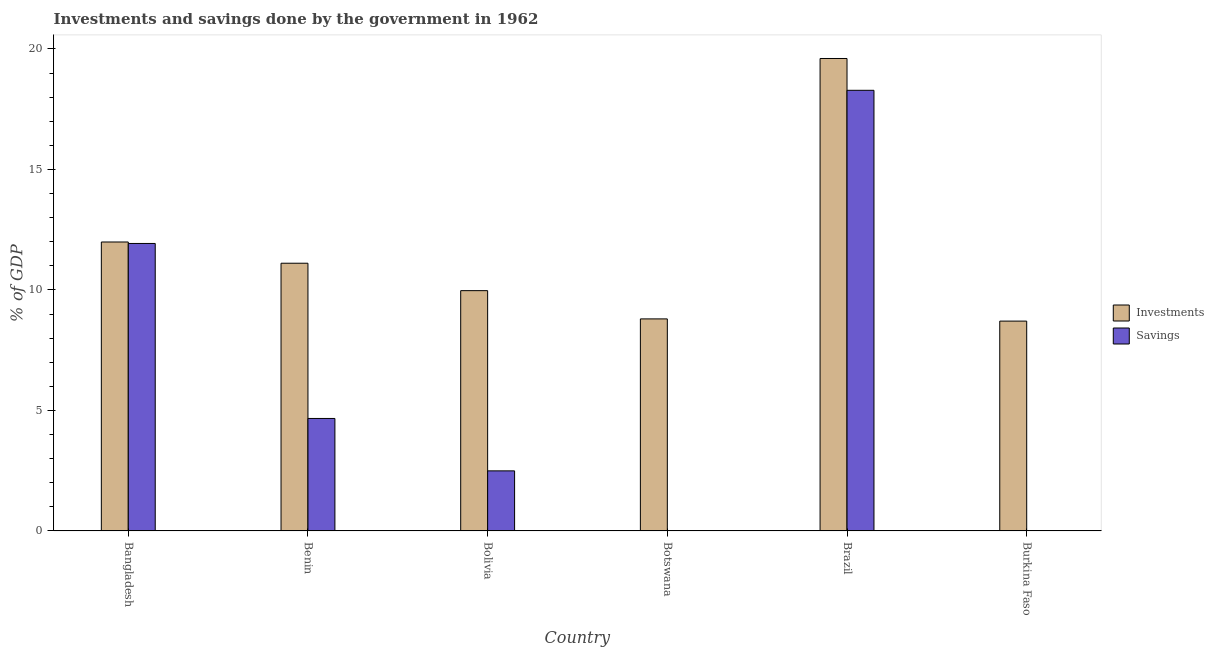How many different coloured bars are there?
Your response must be concise. 2. Are the number of bars per tick equal to the number of legend labels?
Provide a succinct answer. No. How many bars are there on the 3rd tick from the left?
Give a very brief answer. 2. How many bars are there on the 5th tick from the right?
Give a very brief answer. 2. What is the investments of government in Bangladesh?
Provide a short and direct response. 11.99. Across all countries, what is the maximum savings of government?
Your answer should be compact. 18.28. Across all countries, what is the minimum savings of government?
Provide a succinct answer. 0. In which country was the investments of government maximum?
Give a very brief answer. Brazil. What is the total savings of government in the graph?
Ensure brevity in your answer.  37.37. What is the difference between the investments of government in Benin and that in Brazil?
Offer a terse response. -8.5. What is the difference between the investments of government in Burkina Faso and the savings of government in Botswana?
Keep it short and to the point. 8.71. What is the average savings of government per country?
Ensure brevity in your answer.  6.23. What is the difference between the investments of government and savings of government in Bangladesh?
Offer a terse response. 0.06. What is the ratio of the investments of government in Bangladesh to that in Brazil?
Your answer should be very brief. 0.61. Is the investments of government in Botswana less than that in Brazil?
Ensure brevity in your answer.  Yes. Is the difference between the savings of government in Bangladesh and Brazil greater than the difference between the investments of government in Bangladesh and Brazil?
Provide a short and direct response. Yes. What is the difference between the highest and the second highest savings of government?
Offer a very short reply. 6.36. What is the difference between the highest and the lowest savings of government?
Your response must be concise. 18.28. Is the sum of the investments of government in Bangladesh and Brazil greater than the maximum savings of government across all countries?
Keep it short and to the point. Yes. How many bars are there?
Provide a succinct answer. 10. What is the difference between two consecutive major ticks on the Y-axis?
Provide a succinct answer. 5. Does the graph contain grids?
Your answer should be very brief. No. Where does the legend appear in the graph?
Provide a succinct answer. Center right. How are the legend labels stacked?
Provide a short and direct response. Vertical. What is the title of the graph?
Offer a terse response. Investments and savings done by the government in 1962. Does "Investment in Telecom" appear as one of the legend labels in the graph?
Provide a succinct answer. No. What is the label or title of the Y-axis?
Your answer should be compact. % of GDP. What is the % of GDP of Investments in Bangladesh?
Ensure brevity in your answer.  11.99. What is the % of GDP in Savings in Bangladesh?
Make the answer very short. 11.93. What is the % of GDP of Investments in Benin?
Make the answer very short. 11.11. What is the % of GDP in Savings in Benin?
Provide a succinct answer. 4.67. What is the % of GDP of Investments in Bolivia?
Give a very brief answer. 9.97. What is the % of GDP of Savings in Bolivia?
Offer a very short reply. 2.49. What is the % of GDP in Investments in Botswana?
Give a very brief answer. 8.8. What is the % of GDP of Investments in Brazil?
Make the answer very short. 19.6. What is the % of GDP of Savings in Brazil?
Offer a very short reply. 18.28. What is the % of GDP in Investments in Burkina Faso?
Provide a succinct answer. 8.71. Across all countries, what is the maximum % of GDP of Investments?
Keep it short and to the point. 19.6. Across all countries, what is the maximum % of GDP of Savings?
Provide a succinct answer. 18.28. Across all countries, what is the minimum % of GDP of Investments?
Offer a terse response. 8.71. Across all countries, what is the minimum % of GDP in Savings?
Give a very brief answer. 0. What is the total % of GDP in Investments in the graph?
Offer a terse response. 70.18. What is the total % of GDP of Savings in the graph?
Your answer should be compact. 37.37. What is the difference between the % of GDP in Investments in Bangladesh and that in Benin?
Give a very brief answer. 0.88. What is the difference between the % of GDP of Savings in Bangladesh and that in Benin?
Provide a short and direct response. 7.26. What is the difference between the % of GDP of Investments in Bangladesh and that in Bolivia?
Your answer should be very brief. 2.02. What is the difference between the % of GDP in Savings in Bangladesh and that in Bolivia?
Your answer should be compact. 9.44. What is the difference between the % of GDP in Investments in Bangladesh and that in Botswana?
Your answer should be very brief. 3.19. What is the difference between the % of GDP in Investments in Bangladesh and that in Brazil?
Your answer should be very brief. -7.61. What is the difference between the % of GDP in Savings in Bangladesh and that in Brazil?
Provide a short and direct response. -6.36. What is the difference between the % of GDP of Investments in Bangladesh and that in Burkina Faso?
Your response must be concise. 3.28. What is the difference between the % of GDP of Investments in Benin and that in Bolivia?
Provide a succinct answer. 1.14. What is the difference between the % of GDP in Savings in Benin and that in Bolivia?
Give a very brief answer. 2.17. What is the difference between the % of GDP in Investments in Benin and that in Botswana?
Provide a short and direct response. 2.31. What is the difference between the % of GDP in Investments in Benin and that in Brazil?
Provide a succinct answer. -8.5. What is the difference between the % of GDP in Savings in Benin and that in Brazil?
Offer a terse response. -13.62. What is the difference between the % of GDP of Investments in Benin and that in Burkina Faso?
Your answer should be compact. 2.4. What is the difference between the % of GDP in Investments in Bolivia and that in Botswana?
Your answer should be compact. 1.17. What is the difference between the % of GDP of Investments in Bolivia and that in Brazil?
Your answer should be compact. -9.63. What is the difference between the % of GDP in Savings in Bolivia and that in Brazil?
Your answer should be very brief. -15.79. What is the difference between the % of GDP of Investments in Bolivia and that in Burkina Faso?
Offer a terse response. 1.26. What is the difference between the % of GDP in Investments in Botswana and that in Brazil?
Make the answer very short. -10.81. What is the difference between the % of GDP of Investments in Botswana and that in Burkina Faso?
Ensure brevity in your answer.  0.09. What is the difference between the % of GDP in Investments in Brazil and that in Burkina Faso?
Offer a terse response. 10.9. What is the difference between the % of GDP of Investments in Bangladesh and the % of GDP of Savings in Benin?
Provide a short and direct response. 7.32. What is the difference between the % of GDP in Investments in Bangladesh and the % of GDP in Savings in Bolivia?
Provide a succinct answer. 9.5. What is the difference between the % of GDP of Investments in Bangladesh and the % of GDP of Savings in Brazil?
Ensure brevity in your answer.  -6.29. What is the difference between the % of GDP in Investments in Benin and the % of GDP in Savings in Bolivia?
Keep it short and to the point. 8.62. What is the difference between the % of GDP in Investments in Benin and the % of GDP in Savings in Brazil?
Ensure brevity in your answer.  -7.18. What is the difference between the % of GDP of Investments in Bolivia and the % of GDP of Savings in Brazil?
Provide a short and direct response. -8.31. What is the difference between the % of GDP in Investments in Botswana and the % of GDP in Savings in Brazil?
Provide a short and direct response. -9.49. What is the average % of GDP of Investments per country?
Provide a succinct answer. 11.7. What is the average % of GDP of Savings per country?
Provide a succinct answer. 6.23. What is the difference between the % of GDP of Investments and % of GDP of Savings in Bangladesh?
Your answer should be very brief. 0.06. What is the difference between the % of GDP of Investments and % of GDP of Savings in Benin?
Provide a short and direct response. 6.44. What is the difference between the % of GDP of Investments and % of GDP of Savings in Bolivia?
Offer a very short reply. 7.48. What is the difference between the % of GDP of Investments and % of GDP of Savings in Brazil?
Make the answer very short. 1.32. What is the ratio of the % of GDP in Investments in Bangladesh to that in Benin?
Ensure brevity in your answer.  1.08. What is the ratio of the % of GDP of Savings in Bangladesh to that in Benin?
Provide a succinct answer. 2.56. What is the ratio of the % of GDP in Investments in Bangladesh to that in Bolivia?
Provide a short and direct response. 1.2. What is the ratio of the % of GDP of Savings in Bangladesh to that in Bolivia?
Keep it short and to the point. 4.79. What is the ratio of the % of GDP in Investments in Bangladesh to that in Botswana?
Your answer should be compact. 1.36. What is the ratio of the % of GDP of Investments in Bangladesh to that in Brazil?
Provide a succinct answer. 0.61. What is the ratio of the % of GDP in Savings in Bangladesh to that in Brazil?
Ensure brevity in your answer.  0.65. What is the ratio of the % of GDP in Investments in Bangladesh to that in Burkina Faso?
Provide a succinct answer. 1.38. What is the ratio of the % of GDP of Investments in Benin to that in Bolivia?
Your answer should be very brief. 1.11. What is the ratio of the % of GDP of Savings in Benin to that in Bolivia?
Your answer should be very brief. 1.87. What is the ratio of the % of GDP in Investments in Benin to that in Botswana?
Provide a short and direct response. 1.26. What is the ratio of the % of GDP in Investments in Benin to that in Brazil?
Offer a terse response. 0.57. What is the ratio of the % of GDP of Savings in Benin to that in Brazil?
Make the answer very short. 0.26. What is the ratio of the % of GDP in Investments in Benin to that in Burkina Faso?
Provide a short and direct response. 1.28. What is the ratio of the % of GDP of Investments in Bolivia to that in Botswana?
Your answer should be compact. 1.13. What is the ratio of the % of GDP in Investments in Bolivia to that in Brazil?
Your answer should be compact. 0.51. What is the ratio of the % of GDP in Savings in Bolivia to that in Brazil?
Give a very brief answer. 0.14. What is the ratio of the % of GDP of Investments in Bolivia to that in Burkina Faso?
Offer a terse response. 1.15. What is the ratio of the % of GDP of Investments in Botswana to that in Brazil?
Your answer should be compact. 0.45. What is the ratio of the % of GDP of Investments in Botswana to that in Burkina Faso?
Provide a succinct answer. 1.01. What is the ratio of the % of GDP of Investments in Brazil to that in Burkina Faso?
Your answer should be compact. 2.25. What is the difference between the highest and the second highest % of GDP of Investments?
Your answer should be very brief. 7.61. What is the difference between the highest and the second highest % of GDP of Savings?
Offer a very short reply. 6.36. What is the difference between the highest and the lowest % of GDP in Investments?
Keep it short and to the point. 10.9. What is the difference between the highest and the lowest % of GDP of Savings?
Provide a succinct answer. 18.28. 